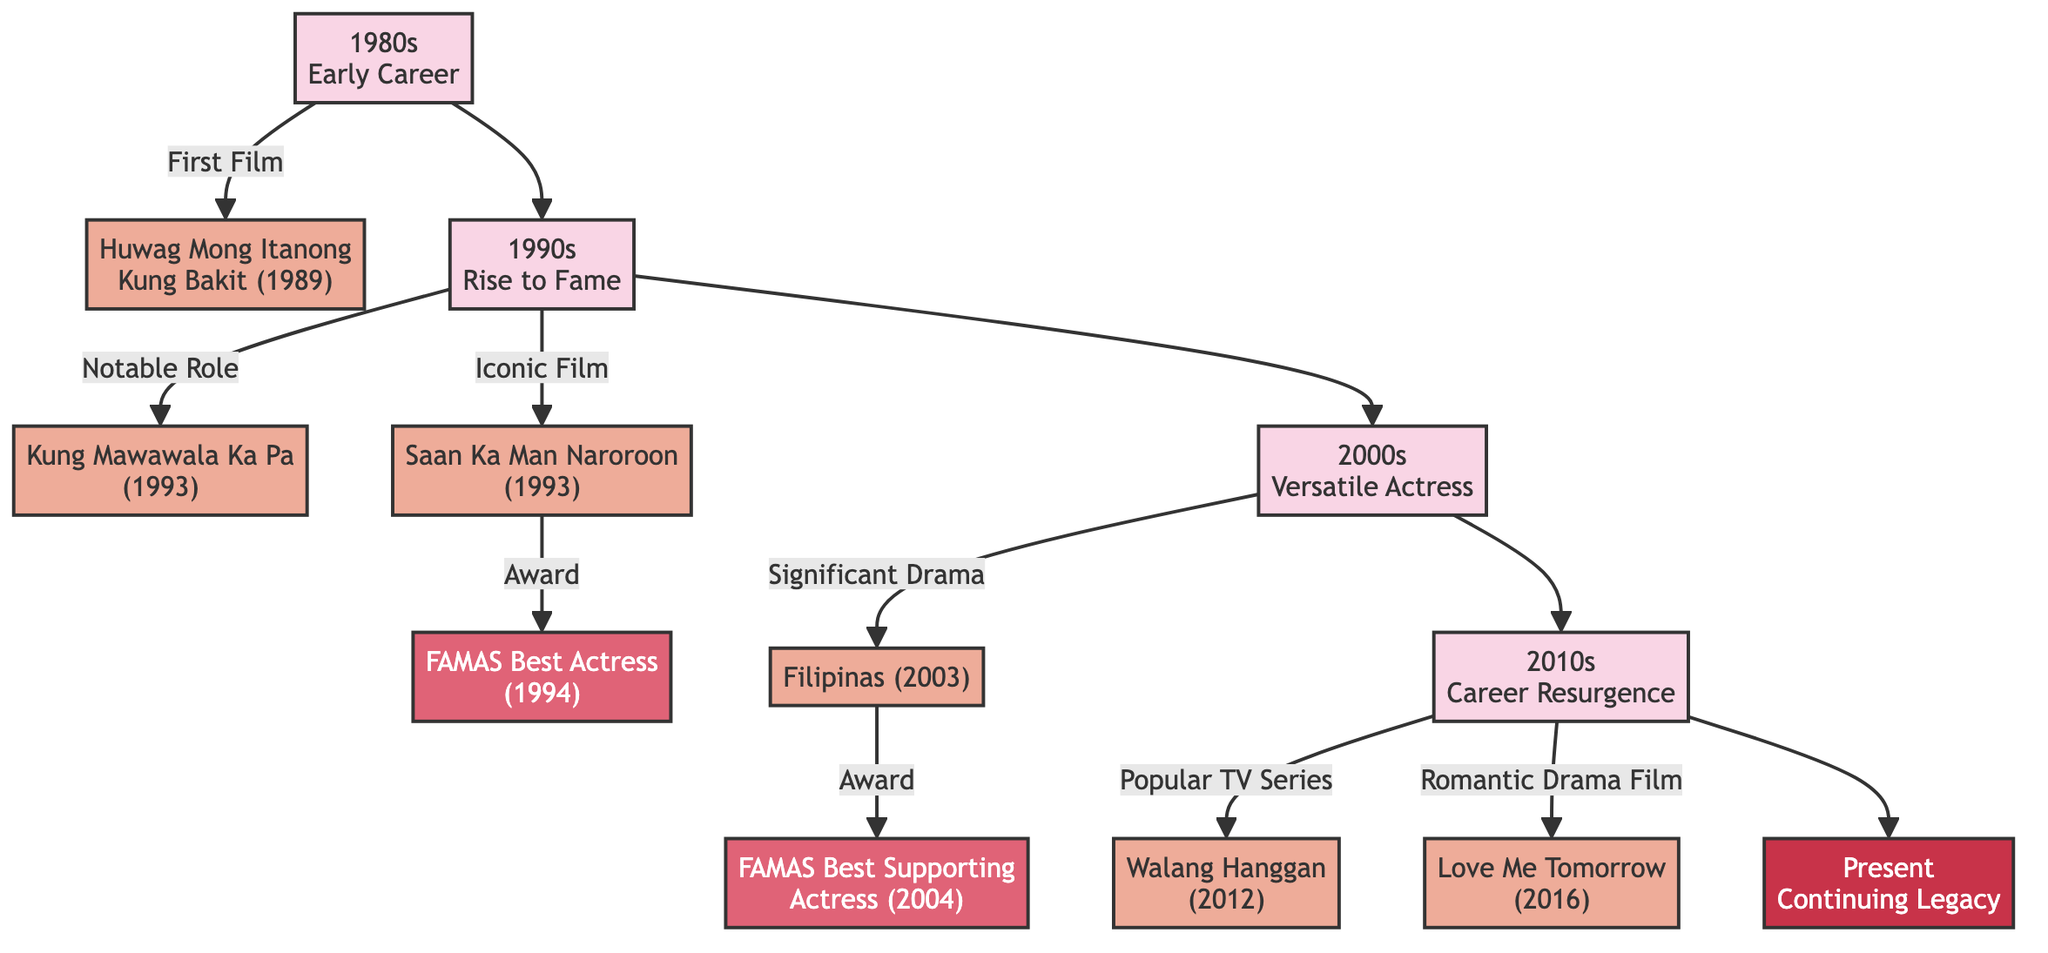What was Dawn Zulueta's first film? The diagram indicates that her first film was "Huwag Mong Itanong Kung Bakit," which is linked to the 1980s.
Answer: Huwag Mong Itanong Kung Bakit Which decade showcases the film "Filipinas"? The film "Filipinas" is connected to the 2000s in the diagram.
Answer: 2000s How many awards are mentioned in the diagram? The diagram mentions two awards: FAMAS Best Actress (1994) and FAMAS Best Supporting Actress (2004). Thus, a count of these results in two awards.
Answer: 2 What role did she play in "Walang Hanggan"? The diagram connects "Walang Hanggan" to the 2010s decade but does not specify the role. However, based on common knowledge, she played a leading role.
Answer: Leading Role Which film led to her winning the FAMAS Best Actress award? The diagram shows that the film "Saan Ka Man Naroroon" is directly linked to the FAMAS Best Actress award; hence, this film is the answer.
Answer: Saan Ka Man Naroroon In which year was the FAMAS Best Supporting Actress awarded? The diagram specifies that the FAMAS Best Supporting Actress was awarded in 2004, connecting this information directly from the link to the film "Filipinas."
Answer: 2004 What decade marks her career resurgence? According to the diagram, the decade depicting her career resurgence is the 2010s.
Answer: 2010s Which film from the 2010s is noted as a romantic drama? The diagram links "Love Me Tomorrow" to the 2010s and classifies it as a romantic drama.
Answer: Love Me Tomorrow What is the common theme in the 1990s films mentioned in the diagram? Both films "Kung Mawawala Ka Pa" and "Saan Ka Man Naroroon" from the 1990s have been described as notable or iconic, indicating her significant roles during that decade.
Answer: Notable/Iconic Roles 